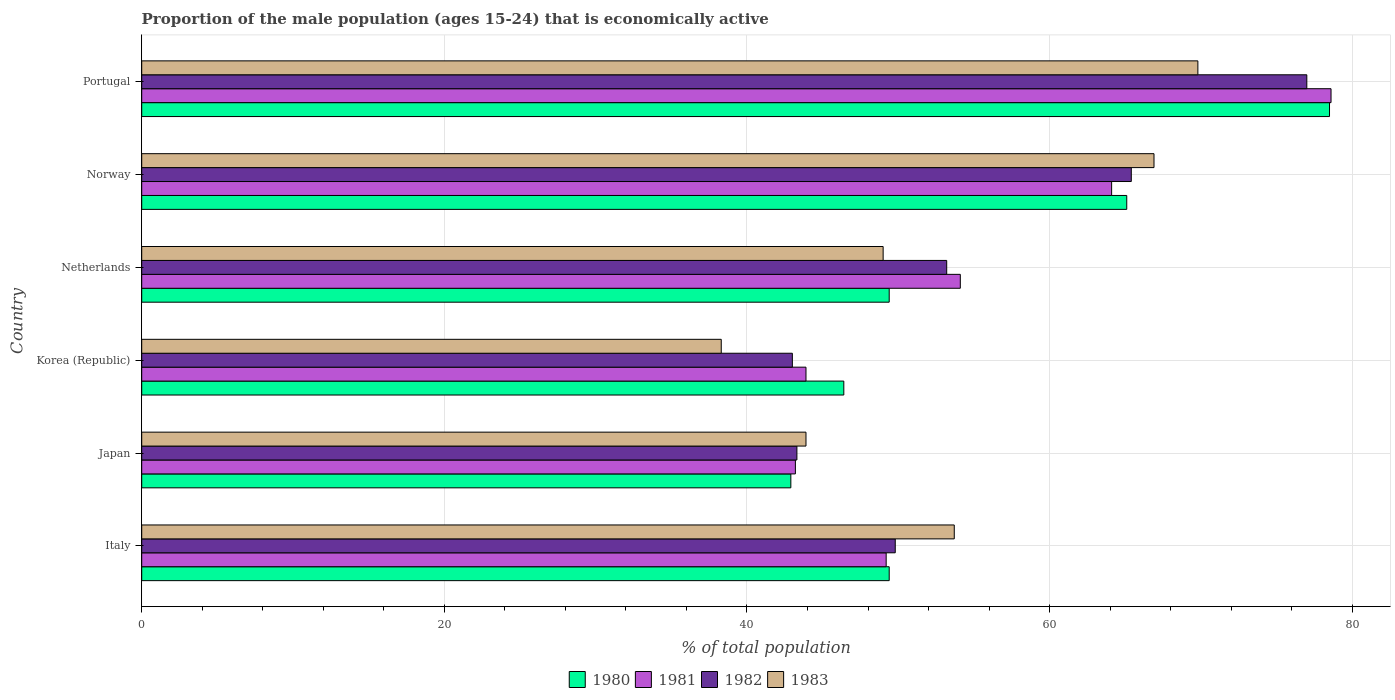Are the number of bars on each tick of the Y-axis equal?
Provide a succinct answer. Yes. How many bars are there on the 6th tick from the bottom?
Provide a succinct answer. 4. What is the proportion of the male population that is economically active in 1982 in Japan?
Provide a succinct answer. 43.3. Across all countries, what is the maximum proportion of the male population that is economically active in 1983?
Keep it short and to the point. 69.8. Across all countries, what is the minimum proportion of the male population that is economically active in 1982?
Offer a very short reply. 43. In which country was the proportion of the male population that is economically active in 1982 maximum?
Ensure brevity in your answer.  Portugal. In which country was the proportion of the male population that is economically active in 1982 minimum?
Make the answer very short. Korea (Republic). What is the total proportion of the male population that is economically active in 1980 in the graph?
Offer a terse response. 331.7. What is the difference between the proportion of the male population that is economically active in 1983 in Italy and that in Korea (Republic)?
Keep it short and to the point. 15.4. What is the difference between the proportion of the male population that is economically active in 1980 in Portugal and the proportion of the male population that is economically active in 1982 in Norway?
Ensure brevity in your answer.  13.1. What is the average proportion of the male population that is economically active in 1981 per country?
Your response must be concise. 55.52. What is the difference between the proportion of the male population that is economically active in 1980 and proportion of the male population that is economically active in 1983 in Korea (Republic)?
Your response must be concise. 8.1. In how many countries, is the proportion of the male population that is economically active in 1981 greater than 20 %?
Provide a succinct answer. 6. What is the ratio of the proportion of the male population that is economically active in 1981 in Japan to that in Norway?
Your answer should be very brief. 0.67. What is the difference between the highest and the second highest proportion of the male population that is economically active in 1983?
Provide a succinct answer. 2.9. What is the difference between the highest and the lowest proportion of the male population that is economically active in 1983?
Offer a very short reply. 31.5. In how many countries, is the proportion of the male population that is economically active in 1983 greater than the average proportion of the male population that is economically active in 1983 taken over all countries?
Ensure brevity in your answer.  3. Is the sum of the proportion of the male population that is economically active in 1983 in Italy and Korea (Republic) greater than the maximum proportion of the male population that is economically active in 1981 across all countries?
Provide a succinct answer. Yes. What does the 1st bar from the top in Netherlands represents?
Provide a short and direct response. 1983. Is it the case that in every country, the sum of the proportion of the male population that is economically active in 1982 and proportion of the male population that is economically active in 1981 is greater than the proportion of the male population that is economically active in 1983?
Your response must be concise. Yes. How many bars are there?
Your answer should be compact. 24. What is the difference between two consecutive major ticks on the X-axis?
Provide a succinct answer. 20. Are the values on the major ticks of X-axis written in scientific E-notation?
Ensure brevity in your answer.  No. Does the graph contain grids?
Offer a very short reply. Yes. Where does the legend appear in the graph?
Provide a short and direct response. Bottom center. How are the legend labels stacked?
Your answer should be compact. Horizontal. What is the title of the graph?
Your answer should be compact. Proportion of the male population (ages 15-24) that is economically active. What is the label or title of the X-axis?
Ensure brevity in your answer.  % of total population. What is the % of total population of 1980 in Italy?
Offer a very short reply. 49.4. What is the % of total population in 1981 in Italy?
Your answer should be compact. 49.2. What is the % of total population in 1982 in Italy?
Ensure brevity in your answer.  49.8. What is the % of total population of 1983 in Italy?
Keep it short and to the point. 53.7. What is the % of total population in 1980 in Japan?
Provide a short and direct response. 42.9. What is the % of total population of 1981 in Japan?
Your answer should be compact. 43.2. What is the % of total population of 1982 in Japan?
Offer a very short reply. 43.3. What is the % of total population in 1983 in Japan?
Your answer should be very brief. 43.9. What is the % of total population in 1980 in Korea (Republic)?
Offer a very short reply. 46.4. What is the % of total population in 1981 in Korea (Republic)?
Your response must be concise. 43.9. What is the % of total population in 1982 in Korea (Republic)?
Give a very brief answer. 43. What is the % of total population in 1983 in Korea (Republic)?
Your answer should be compact. 38.3. What is the % of total population of 1980 in Netherlands?
Provide a succinct answer. 49.4. What is the % of total population of 1981 in Netherlands?
Your answer should be compact. 54.1. What is the % of total population of 1982 in Netherlands?
Keep it short and to the point. 53.2. What is the % of total population of 1980 in Norway?
Your answer should be compact. 65.1. What is the % of total population in 1981 in Norway?
Your answer should be compact. 64.1. What is the % of total population in 1982 in Norway?
Keep it short and to the point. 65.4. What is the % of total population of 1983 in Norway?
Provide a succinct answer. 66.9. What is the % of total population in 1980 in Portugal?
Offer a very short reply. 78.5. What is the % of total population in 1981 in Portugal?
Give a very brief answer. 78.6. What is the % of total population of 1983 in Portugal?
Give a very brief answer. 69.8. Across all countries, what is the maximum % of total population of 1980?
Ensure brevity in your answer.  78.5. Across all countries, what is the maximum % of total population in 1981?
Make the answer very short. 78.6. Across all countries, what is the maximum % of total population of 1983?
Provide a short and direct response. 69.8. Across all countries, what is the minimum % of total population of 1980?
Make the answer very short. 42.9. Across all countries, what is the minimum % of total population of 1981?
Ensure brevity in your answer.  43.2. Across all countries, what is the minimum % of total population of 1983?
Provide a short and direct response. 38.3. What is the total % of total population in 1980 in the graph?
Provide a short and direct response. 331.7. What is the total % of total population in 1981 in the graph?
Your answer should be very brief. 333.1. What is the total % of total population in 1982 in the graph?
Your response must be concise. 331.7. What is the total % of total population in 1983 in the graph?
Make the answer very short. 321.6. What is the difference between the % of total population of 1981 in Italy and that in Japan?
Make the answer very short. 6. What is the difference between the % of total population of 1981 in Italy and that in Korea (Republic)?
Keep it short and to the point. 5.3. What is the difference between the % of total population in 1982 in Italy and that in Korea (Republic)?
Make the answer very short. 6.8. What is the difference between the % of total population in 1983 in Italy and that in Korea (Republic)?
Make the answer very short. 15.4. What is the difference between the % of total population in 1981 in Italy and that in Netherlands?
Ensure brevity in your answer.  -4.9. What is the difference between the % of total population of 1983 in Italy and that in Netherlands?
Your answer should be very brief. 4.7. What is the difference between the % of total population in 1980 in Italy and that in Norway?
Make the answer very short. -15.7. What is the difference between the % of total population in 1981 in Italy and that in Norway?
Your response must be concise. -14.9. What is the difference between the % of total population in 1982 in Italy and that in Norway?
Offer a very short reply. -15.6. What is the difference between the % of total population in 1983 in Italy and that in Norway?
Provide a short and direct response. -13.2. What is the difference between the % of total population of 1980 in Italy and that in Portugal?
Provide a short and direct response. -29.1. What is the difference between the % of total population of 1981 in Italy and that in Portugal?
Give a very brief answer. -29.4. What is the difference between the % of total population of 1982 in Italy and that in Portugal?
Offer a terse response. -27.2. What is the difference between the % of total population of 1983 in Italy and that in Portugal?
Give a very brief answer. -16.1. What is the difference between the % of total population of 1981 in Japan and that in Korea (Republic)?
Provide a short and direct response. -0.7. What is the difference between the % of total population in 1982 in Japan and that in Korea (Republic)?
Provide a short and direct response. 0.3. What is the difference between the % of total population in 1980 in Japan and that in Netherlands?
Your answer should be compact. -6.5. What is the difference between the % of total population of 1981 in Japan and that in Netherlands?
Make the answer very short. -10.9. What is the difference between the % of total population in 1983 in Japan and that in Netherlands?
Provide a succinct answer. -5.1. What is the difference between the % of total population of 1980 in Japan and that in Norway?
Your answer should be compact. -22.2. What is the difference between the % of total population of 1981 in Japan and that in Norway?
Make the answer very short. -20.9. What is the difference between the % of total population of 1982 in Japan and that in Norway?
Give a very brief answer. -22.1. What is the difference between the % of total population of 1983 in Japan and that in Norway?
Offer a terse response. -23. What is the difference between the % of total population in 1980 in Japan and that in Portugal?
Your answer should be very brief. -35.6. What is the difference between the % of total population in 1981 in Japan and that in Portugal?
Give a very brief answer. -35.4. What is the difference between the % of total population in 1982 in Japan and that in Portugal?
Provide a short and direct response. -33.7. What is the difference between the % of total population of 1983 in Japan and that in Portugal?
Your response must be concise. -25.9. What is the difference between the % of total population of 1980 in Korea (Republic) and that in Netherlands?
Ensure brevity in your answer.  -3. What is the difference between the % of total population in 1981 in Korea (Republic) and that in Netherlands?
Offer a very short reply. -10.2. What is the difference between the % of total population in 1983 in Korea (Republic) and that in Netherlands?
Offer a very short reply. -10.7. What is the difference between the % of total population in 1980 in Korea (Republic) and that in Norway?
Make the answer very short. -18.7. What is the difference between the % of total population of 1981 in Korea (Republic) and that in Norway?
Your answer should be compact. -20.2. What is the difference between the % of total population in 1982 in Korea (Republic) and that in Norway?
Give a very brief answer. -22.4. What is the difference between the % of total population in 1983 in Korea (Republic) and that in Norway?
Give a very brief answer. -28.6. What is the difference between the % of total population in 1980 in Korea (Republic) and that in Portugal?
Offer a terse response. -32.1. What is the difference between the % of total population of 1981 in Korea (Republic) and that in Portugal?
Make the answer very short. -34.7. What is the difference between the % of total population of 1982 in Korea (Republic) and that in Portugal?
Your answer should be very brief. -34. What is the difference between the % of total population in 1983 in Korea (Republic) and that in Portugal?
Make the answer very short. -31.5. What is the difference between the % of total population of 1980 in Netherlands and that in Norway?
Provide a short and direct response. -15.7. What is the difference between the % of total population of 1981 in Netherlands and that in Norway?
Provide a short and direct response. -10. What is the difference between the % of total population in 1982 in Netherlands and that in Norway?
Provide a succinct answer. -12.2. What is the difference between the % of total population of 1983 in Netherlands and that in Norway?
Make the answer very short. -17.9. What is the difference between the % of total population of 1980 in Netherlands and that in Portugal?
Provide a short and direct response. -29.1. What is the difference between the % of total population in 1981 in Netherlands and that in Portugal?
Your answer should be compact. -24.5. What is the difference between the % of total population in 1982 in Netherlands and that in Portugal?
Provide a short and direct response. -23.8. What is the difference between the % of total population in 1983 in Netherlands and that in Portugal?
Provide a short and direct response. -20.8. What is the difference between the % of total population in 1980 in Norway and that in Portugal?
Ensure brevity in your answer.  -13.4. What is the difference between the % of total population of 1983 in Norway and that in Portugal?
Offer a terse response. -2.9. What is the difference between the % of total population in 1980 in Italy and the % of total population in 1983 in Japan?
Your response must be concise. 5.5. What is the difference between the % of total population in 1980 in Italy and the % of total population in 1983 in Korea (Republic)?
Your answer should be compact. 11.1. What is the difference between the % of total population in 1981 in Italy and the % of total population in 1982 in Korea (Republic)?
Give a very brief answer. 6.2. What is the difference between the % of total population of 1981 in Italy and the % of total population of 1983 in Korea (Republic)?
Keep it short and to the point. 10.9. What is the difference between the % of total population in 1982 in Italy and the % of total population in 1983 in Korea (Republic)?
Make the answer very short. 11.5. What is the difference between the % of total population of 1980 in Italy and the % of total population of 1981 in Netherlands?
Your response must be concise. -4.7. What is the difference between the % of total population of 1981 in Italy and the % of total population of 1982 in Netherlands?
Ensure brevity in your answer.  -4. What is the difference between the % of total population of 1982 in Italy and the % of total population of 1983 in Netherlands?
Ensure brevity in your answer.  0.8. What is the difference between the % of total population of 1980 in Italy and the % of total population of 1981 in Norway?
Give a very brief answer. -14.7. What is the difference between the % of total population of 1980 in Italy and the % of total population of 1983 in Norway?
Give a very brief answer. -17.5. What is the difference between the % of total population of 1981 in Italy and the % of total population of 1982 in Norway?
Make the answer very short. -16.2. What is the difference between the % of total population in 1981 in Italy and the % of total population in 1983 in Norway?
Make the answer very short. -17.7. What is the difference between the % of total population in 1982 in Italy and the % of total population in 1983 in Norway?
Offer a very short reply. -17.1. What is the difference between the % of total population of 1980 in Italy and the % of total population of 1981 in Portugal?
Provide a short and direct response. -29.2. What is the difference between the % of total population of 1980 in Italy and the % of total population of 1982 in Portugal?
Make the answer very short. -27.6. What is the difference between the % of total population in 1980 in Italy and the % of total population in 1983 in Portugal?
Your answer should be compact. -20.4. What is the difference between the % of total population in 1981 in Italy and the % of total population in 1982 in Portugal?
Ensure brevity in your answer.  -27.8. What is the difference between the % of total population of 1981 in Italy and the % of total population of 1983 in Portugal?
Your response must be concise. -20.6. What is the difference between the % of total population in 1982 in Italy and the % of total population in 1983 in Portugal?
Keep it short and to the point. -20. What is the difference between the % of total population in 1980 in Japan and the % of total population in 1983 in Korea (Republic)?
Provide a short and direct response. 4.6. What is the difference between the % of total population in 1981 in Japan and the % of total population in 1982 in Korea (Republic)?
Your answer should be very brief. 0.2. What is the difference between the % of total population in 1980 in Japan and the % of total population in 1983 in Netherlands?
Make the answer very short. -6.1. What is the difference between the % of total population of 1982 in Japan and the % of total population of 1983 in Netherlands?
Give a very brief answer. -5.7. What is the difference between the % of total population of 1980 in Japan and the % of total population of 1981 in Norway?
Offer a terse response. -21.2. What is the difference between the % of total population in 1980 in Japan and the % of total population in 1982 in Norway?
Offer a very short reply. -22.5. What is the difference between the % of total population in 1981 in Japan and the % of total population in 1982 in Norway?
Keep it short and to the point. -22.2. What is the difference between the % of total population in 1981 in Japan and the % of total population in 1983 in Norway?
Your response must be concise. -23.7. What is the difference between the % of total population of 1982 in Japan and the % of total population of 1983 in Norway?
Give a very brief answer. -23.6. What is the difference between the % of total population in 1980 in Japan and the % of total population in 1981 in Portugal?
Your answer should be very brief. -35.7. What is the difference between the % of total population of 1980 in Japan and the % of total population of 1982 in Portugal?
Your answer should be very brief. -34.1. What is the difference between the % of total population in 1980 in Japan and the % of total population in 1983 in Portugal?
Your answer should be very brief. -26.9. What is the difference between the % of total population in 1981 in Japan and the % of total population in 1982 in Portugal?
Provide a succinct answer. -33.8. What is the difference between the % of total population of 1981 in Japan and the % of total population of 1983 in Portugal?
Make the answer very short. -26.6. What is the difference between the % of total population of 1982 in Japan and the % of total population of 1983 in Portugal?
Ensure brevity in your answer.  -26.5. What is the difference between the % of total population in 1980 in Korea (Republic) and the % of total population in 1981 in Netherlands?
Offer a terse response. -7.7. What is the difference between the % of total population of 1980 in Korea (Republic) and the % of total population of 1983 in Netherlands?
Ensure brevity in your answer.  -2.6. What is the difference between the % of total population of 1980 in Korea (Republic) and the % of total population of 1981 in Norway?
Your answer should be compact. -17.7. What is the difference between the % of total population in 1980 in Korea (Republic) and the % of total population in 1982 in Norway?
Provide a short and direct response. -19. What is the difference between the % of total population in 1980 in Korea (Republic) and the % of total population in 1983 in Norway?
Offer a very short reply. -20.5. What is the difference between the % of total population in 1981 in Korea (Republic) and the % of total population in 1982 in Norway?
Offer a very short reply. -21.5. What is the difference between the % of total population in 1981 in Korea (Republic) and the % of total population in 1983 in Norway?
Your response must be concise. -23. What is the difference between the % of total population of 1982 in Korea (Republic) and the % of total population of 1983 in Norway?
Keep it short and to the point. -23.9. What is the difference between the % of total population in 1980 in Korea (Republic) and the % of total population in 1981 in Portugal?
Make the answer very short. -32.2. What is the difference between the % of total population of 1980 in Korea (Republic) and the % of total population of 1982 in Portugal?
Your response must be concise. -30.6. What is the difference between the % of total population of 1980 in Korea (Republic) and the % of total population of 1983 in Portugal?
Offer a terse response. -23.4. What is the difference between the % of total population in 1981 in Korea (Republic) and the % of total population in 1982 in Portugal?
Offer a very short reply. -33.1. What is the difference between the % of total population of 1981 in Korea (Republic) and the % of total population of 1983 in Portugal?
Offer a very short reply. -25.9. What is the difference between the % of total population of 1982 in Korea (Republic) and the % of total population of 1983 in Portugal?
Your answer should be very brief. -26.8. What is the difference between the % of total population in 1980 in Netherlands and the % of total population in 1981 in Norway?
Your response must be concise. -14.7. What is the difference between the % of total population in 1980 in Netherlands and the % of total population in 1983 in Norway?
Provide a short and direct response. -17.5. What is the difference between the % of total population in 1982 in Netherlands and the % of total population in 1983 in Norway?
Your answer should be very brief. -13.7. What is the difference between the % of total population in 1980 in Netherlands and the % of total population in 1981 in Portugal?
Ensure brevity in your answer.  -29.2. What is the difference between the % of total population of 1980 in Netherlands and the % of total population of 1982 in Portugal?
Make the answer very short. -27.6. What is the difference between the % of total population of 1980 in Netherlands and the % of total population of 1983 in Portugal?
Your response must be concise. -20.4. What is the difference between the % of total population of 1981 in Netherlands and the % of total population of 1982 in Portugal?
Offer a very short reply. -22.9. What is the difference between the % of total population in 1981 in Netherlands and the % of total population in 1983 in Portugal?
Provide a short and direct response. -15.7. What is the difference between the % of total population in 1982 in Netherlands and the % of total population in 1983 in Portugal?
Offer a terse response. -16.6. What is the difference between the % of total population of 1980 in Norway and the % of total population of 1983 in Portugal?
Your response must be concise. -4.7. What is the difference between the % of total population in 1981 in Norway and the % of total population in 1982 in Portugal?
Your response must be concise. -12.9. What is the average % of total population of 1980 per country?
Ensure brevity in your answer.  55.28. What is the average % of total population of 1981 per country?
Your answer should be compact. 55.52. What is the average % of total population in 1982 per country?
Your response must be concise. 55.28. What is the average % of total population in 1983 per country?
Your answer should be very brief. 53.6. What is the difference between the % of total population in 1980 and % of total population in 1982 in Italy?
Provide a succinct answer. -0.4. What is the difference between the % of total population in 1980 and % of total population in 1983 in Italy?
Your answer should be very brief. -4.3. What is the difference between the % of total population of 1981 and % of total population of 1982 in Italy?
Give a very brief answer. -0.6. What is the difference between the % of total population in 1981 and % of total population in 1983 in Italy?
Provide a succinct answer. -4.5. What is the difference between the % of total population in 1980 and % of total population in 1981 in Japan?
Keep it short and to the point. -0.3. What is the difference between the % of total population of 1980 and % of total population of 1983 in Japan?
Your answer should be very brief. -1. What is the difference between the % of total population of 1981 and % of total population of 1982 in Japan?
Give a very brief answer. -0.1. What is the difference between the % of total population in 1981 and % of total population in 1983 in Japan?
Ensure brevity in your answer.  -0.7. What is the difference between the % of total population in 1982 and % of total population in 1983 in Japan?
Keep it short and to the point. -0.6. What is the difference between the % of total population in 1980 and % of total population in 1981 in Korea (Republic)?
Your response must be concise. 2.5. What is the difference between the % of total population in 1980 and % of total population in 1983 in Korea (Republic)?
Ensure brevity in your answer.  8.1. What is the difference between the % of total population of 1980 and % of total population of 1981 in Netherlands?
Keep it short and to the point. -4.7. What is the difference between the % of total population in 1981 and % of total population in 1982 in Netherlands?
Make the answer very short. 0.9. What is the difference between the % of total population of 1981 and % of total population of 1983 in Netherlands?
Provide a succinct answer. 5.1. What is the difference between the % of total population in 1982 and % of total population in 1983 in Netherlands?
Offer a very short reply. 4.2. What is the difference between the % of total population of 1980 and % of total population of 1981 in Norway?
Your answer should be compact. 1. What is the difference between the % of total population of 1980 and % of total population of 1983 in Norway?
Offer a very short reply. -1.8. What is the difference between the % of total population in 1981 and % of total population in 1983 in Norway?
Make the answer very short. -2.8. What is the difference between the % of total population in 1980 and % of total population in 1983 in Portugal?
Offer a terse response. 8.7. What is the difference between the % of total population in 1981 and % of total population in 1982 in Portugal?
Give a very brief answer. 1.6. What is the ratio of the % of total population in 1980 in Italy to that in Japan?
Offer a terse response. 1.15. What is the ratio of the % of total population of 1981 in Italy to that in Japan?
Your response must be concise. 1.14. What is the ratio of the % of total population of 1982 in Italy to that in Japan?
Your answer should be very brief. 1.15. What is the ratio of the % of total population of 1983 in Italy to that in Japan?
Your answer should be compact. 1.22. What is the ratio of the % of total population in 1980 in Italy to that in Korea (Republic)?
Make the answer very short. 1.06. What is the ratio of the % of total population in 1981 in Italy to that in Korea (Republic)?
Ensure brevity in your answer.  1.12. What is the ratio of the % of total population of 1982 in Italy to that in Korea (Republic)?
Provide a succinct answer. 1.16. What is the ratio of the % of total population of 1983 in Italy to that in Korea (Republic)?
Offer a very short reply. 1.4. What is the ratio of the % of total population in 1981 in Italy to that in Netherlands?
Provide a short and direct response. 0.91. What is the ratio of the % of total population of 1982 in Italy to that in Netherlands?
Give a very brief answer. 0.94. What is the ratio of the % of total population of 1983 in Italy to that in Netherlands?
Ensure brevity in your answer.  1.1. What is the ratio of the % of total population of 1980 in Italy to that in Norway?
Your answer should be very brief. 0.76. What is the ratio of the % of total population in 1981 in Italy to that in Norway?
Your answer should be compact. 0.77. What is the ratio of the % of total population of 1982 in Italy to that in Norway?
Your answer should be compact. 0.76. What is the ratio of the % of total population of 1983 in Italy to that in Norway?
Keep it short and to the point. 0.8. What is the ratio of the % of total population in 1980 in Italy to that in Portugal?
Your answer should be compact. 0.63. What is the ratio of the % of total population of 1981 in Italy to that in Portugal?
Provide a succinct answer. 0.63. What is the ratio of the % of total population of 1982 in Italy to that in Portugal?
Ensure brevity in your answer.  0.65. What is the ratio of the % of total population in 1983 in Italy to that in Portugal?
Offer a very short reply. 0.77. What is the ratio of the % of total population in 1980 in Japan to that in Korea (Republic)?
Keep it short and to the point. 0.92. What is the ratio of the % of total population of 1981 in Japan to that in Korea (Republic)?
Your answer should be compact. 0.98. What is the ratio of the % of total population of 1983 in Japan to that in Korea (Republic)?
Provide a succinct answer. 1.15. What is the ratio of the % of total population of 1980 in Japan to that in Netherlands?
Offer a terse response. 0.87. What is the ratio of the % of total population of 1981 in Japan to that in Netherlands?
Your answer should be compact. 0.8. What is the ratio of the % of total population in 1982 in Japan to that in Netherlands?
Your response must be concise. 0.81. What is the ratio of the % of total population in 1983 in Japan to that in Netherlands?
Provide a short and direct response. 0.9. What is the ratio of the % of total population in 1980 in Japan to that in Norway?
Your response must be concise. 0.66. What is the ratio of the % of total population of 1981 in Japan to that in Norway?
Offer a very short reply. 0.67. What is the ratio of the % of total population of 1982 in Japan to that in Norway?
Your answer should be compact. 0.66. What is the ratio of the % of total population in 1983 in Japan to that in Norway?
Offer a very short reply. 0.66. What is the ratio of the % of total population in 1980 in Japan to that in Portugal?
Ensure brevity in your answer.  0.55. What is the ratio of the % of total population of 1981 in Japan to that in Portugal?
Keep it short and to the point. 0.55. What is the ratio of the % of total population in 1982 in Japan to that in Portugal?
Offer a very short reply. 0.56. What is the ratio of the % of total population in 1983 in Japan to that in Portugal?
Offer a terse response. 0.63. What is the ratio of the % of total population in 1980 in Korea (Republic) to that in Netherlands?
Provide a short and direct response. 0.94. What is the ratio of the % of total population in 1981 in Korea (Republic) to that in Netherlands?
Offer a terse response. 0.81. What is the ratio of the % of total population of 1982 in Korea (Republic) to that in Netherlands?
Your answer should be compact. 0.81. What is the ratio of the % of total population in 1983 in Korea (Republic) to that in Netherlands?
Ensure brevity in your answer.  0.78. What is the ratio of the % of total population of 1980 in Korea (Republic) to that in Norway?
Your response must be concise. 0.71. What is the ratio of the % of total population of 1981 in Korea (Republic) to that in Norway?
Provide a succinct answer. 0.68. What is the ratio of the % of total population of 1982 in Korea (Republic) to that in Norway?
Make the answer very short. 0.66. What is the ratio of the % of total population in 1983 in Korea (Republic) to that in Norway?
Your response must be concise. 0.57. What is the ratio of the % of total population of 1980 in Korea (Republic) to that in Portugal?
Ensure brevity in your answer.  0.59. What is the ratio of the % of total population of 1981 in Korea (Republic) to that in Portugal?
Provide a short and direct response. 0.56. What is the ratio of the % of total population of 1982 in Korea (Republic) to that in Portugal?
Ensure brevity in your answer.  0.56. What is the ratio of the % of total population of 1983 in Korea (Republic) to that in Portugal?
Offer a very short reply. 0.55. What is the ratio of the % of total population in 1980 in Netherlands to that in Norway?
Your response must be concise. 0.76. What is the ratio of the % of total population in 1981 in Netherlands to that in Norway?
Provide a succinct answer. 0.84. What is the ratio of the % of total population in 1982 in Netherlands to that in Norway?
Offer a terse response. 0.81. What is the ratio of the % of total population in 1983 in Netherlands to that in Norway?
Provide a succinct answer. 0.73. What is the ratio of the % of total population in 1980 in Netherlands to that in Portugal?
Your response must be concise. 0.63. What is the ratio of the % of total population in 1981 in Netherlands to that in Portugal?
Make the answer very short. 0.69. What is the ratio of the % of total population in 1982 in Netherlands to that in Portugal?
Offer a very short reply. 0.69. What is the ratio of the % of total population of 1983 in Netherlands to that in Portugal?
Offer a terse response. 0.7. What is the ratio of the % of total population of 1980 in Norway to that in Portugal?
Give a very brief answer. 0.83. What is the ratio of the % of total population in 1981 in Norway to that in Portugal?
Your answer should be very brief. 0.82. What is the ratio of the % of total population of 1982 in Norway to that in Portugal?
Give a very brief answer. 0.85. What is the ratio of the % of total population in 1983 in Norway to that in Portugal?
Your answer should be very brief. 0.96. What is the difference between the highest and the second highest % of total population of 1980?
Your answer should be compact. 13.4. What is the difference between the highest and the second highest % of total population of 1981?
Provide a short and direct response. 14.5. What is the difference between the highest and the second highest % of total population in 1982?
Your response must be concise. 11.6. What is the difference between the highest and the lowest % of total population of 1980?
Offer a terse response. 35.6. What is the difference between the highest and the lowest % of total population of 1981?
Your response must be concise. 35.4. What is the difference between the highest and the lowest % of total population of 1982?
Ensure brevity in your answer.  34. What is the difference between the highest and the lowest % of total population in 1983?
Offer a very short reply. 31.5. 